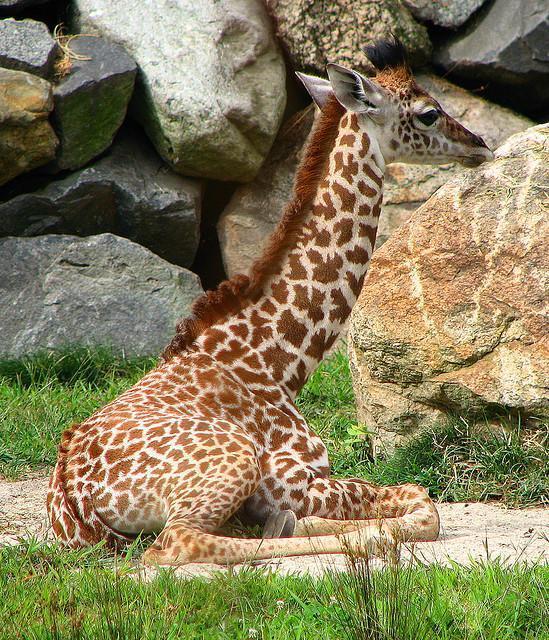How many giraffes are present?
Give a very brief answer. 1. How many giraffes are in the photo?
Give a very brief answer. 1. How many giraffes are in the picture?
Give a very brief answer. 1. How many people are standing on surfboards?
Give a very brief answer. 0. 